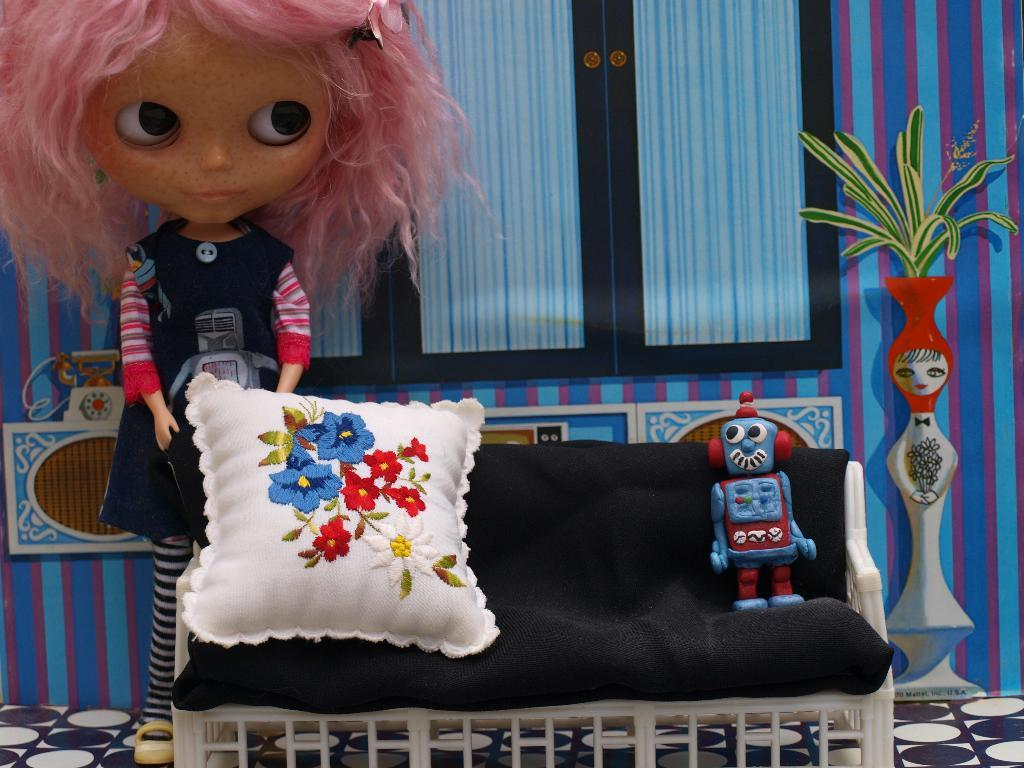What object is placed on the sofa in the image? There is a toy on the sofa. What other object can be seen on the sofa? There is a pillow on the sofa. What is located beside the sofa in the image? There is a doll beside the sofa. What is attached to the wall in the image? There is a frame attached to the wall. What type of toy resembles a flower pot in the image? There is a toy that resembles a flower pot in the image. What architectural feature is visible in the image? There are windows in the image. What type of soap is being used to clean the windows in the image? There is no soap or cleaning activity visible in the image; it only shows a toy, a pillow, a doll, a frame, a toy resembling a flower pot, and windows. 